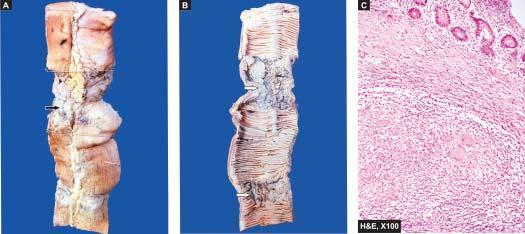what shows characteristic transverse ulcers and two strictures?
Answer the question using a single word or phrase. Lumen 